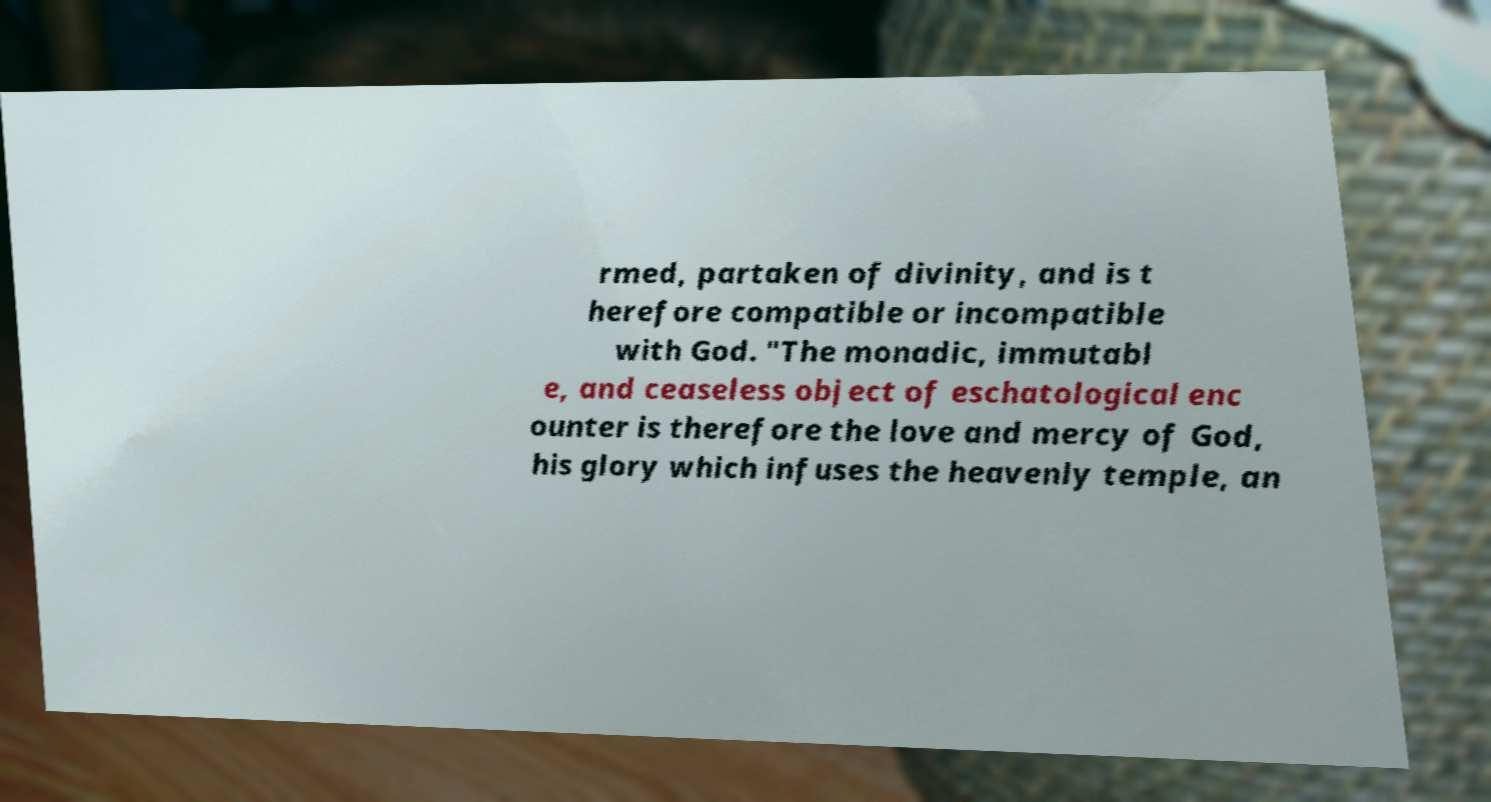Could you assist in decoding the text presented in this image and type it out clearly? rmed, partaken of divinity, and is t herefore compatible or incompatible with God. "The monadic, immutabl e, and ceaseless object of eschatological enc ounter is therefore the love and mercy of God, his glory which infuses the heavenly temple, an 